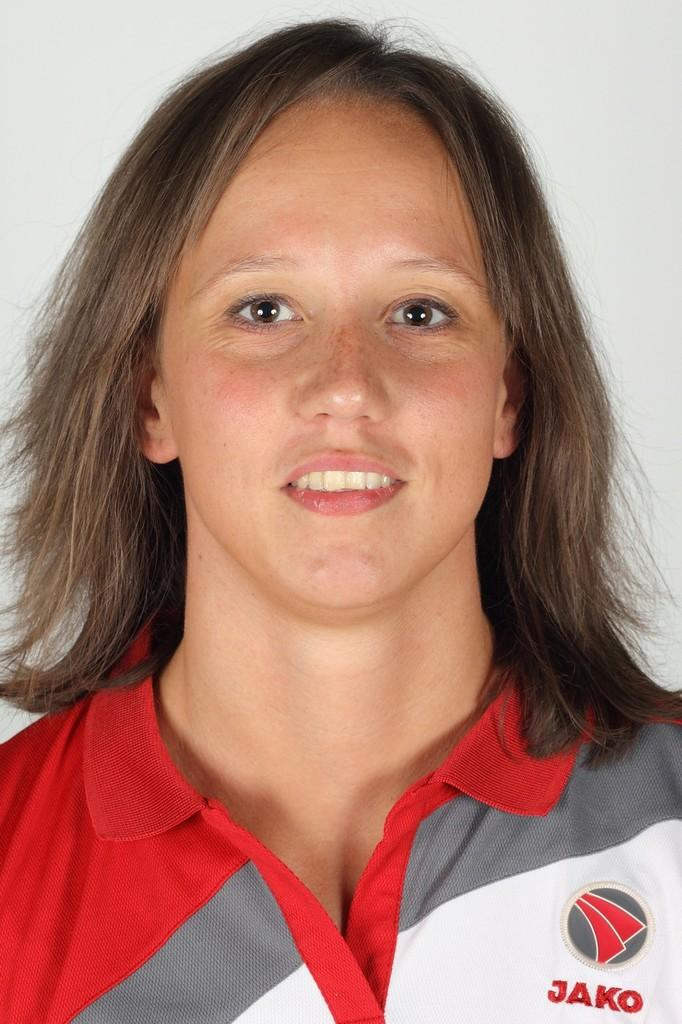<image>
Share a concise interpretation of the image provided. a girl wearing a white, red and white jako sports shirt 